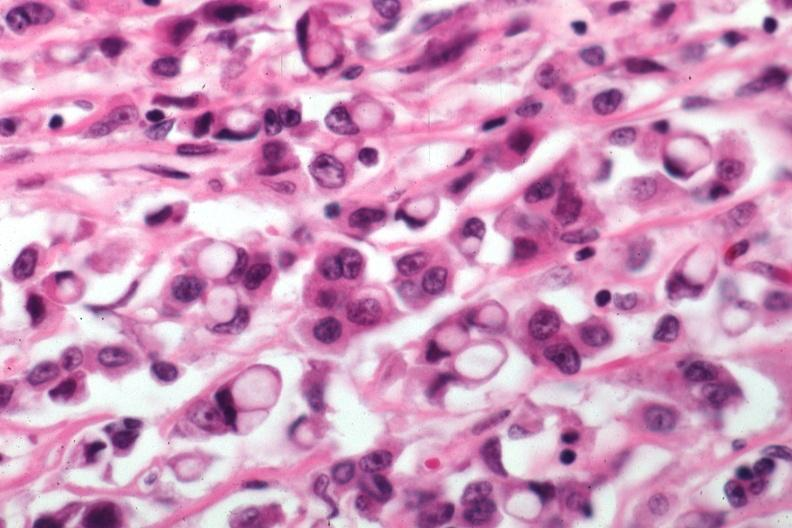s retroperitoneum present?
Answer the question using a single word or phrase. No 